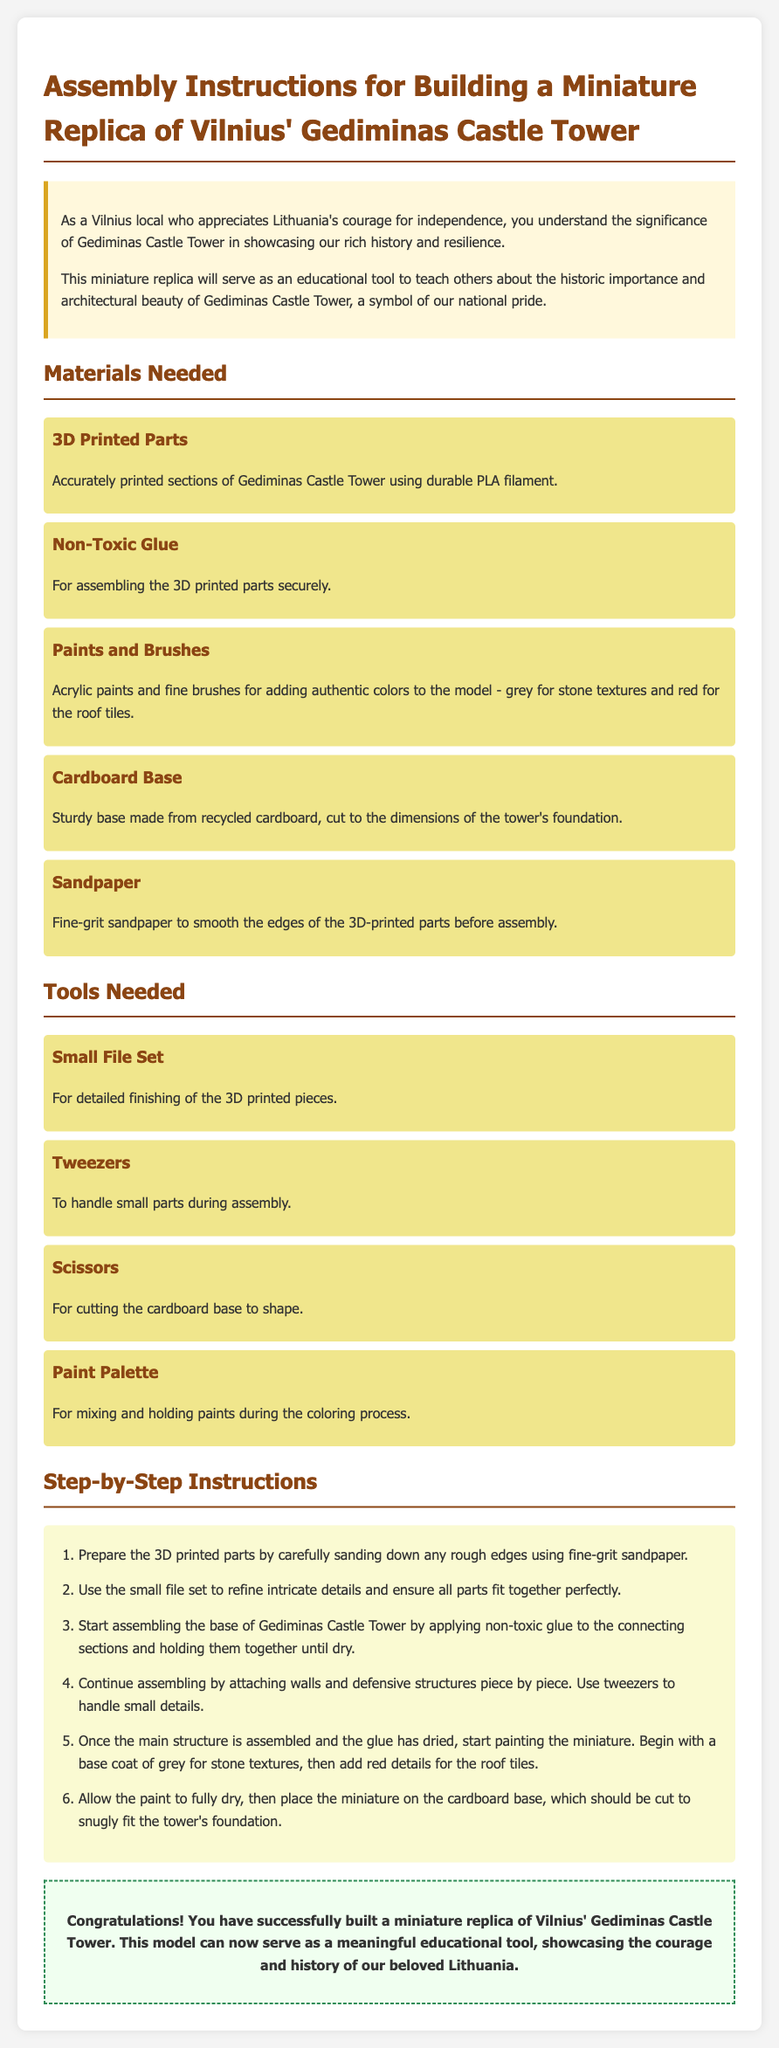What is the title of the document? The title of the document is indicated in the header as "Assembly Instructions for Building a Miniature Replica of Vilnius' Gediminas Castle Tower".
Answer: Assembly Instructions for Building a Miniature Replica of Vilnius' Gediminas Castle Tower How many materials are listed? The materials section lists five distinct items required for the assembly.
Answer: 5 What type of glue is mentioned? The document specifies the kind of glue needed for assembly, which is mentioned as "non-toxic glue".
Answer: Non-Toxic Glue What is the first step in the assembly instructions? The first step details preparing the 3D printed parts by sanding down rough edges.
Answer: Prepare the 3D printed parts by carefully sanding down any rough edges What colors are suggested for painting the model? The document mentions two specific colors for painting, grey for stone textures and red for roof tiles.
Answer: Grey for stone textures, red for roof tiles What tool is recommended for cutting the cardboard base? The tools section specifies scissors as the tool for shaping the cardboard base.
Answer: Scissors How is the conclusion framed in the document? The conclusion recognizes the successful completion of the replica and its educational purpose regarding Lithuania's courage and history.
Answer: Congratulations! You have successfully built a miniature replica of Vilnius' Gediminas Castle Tower What is the purpose of building the miniature replica? The document mentions the educational objective of the replica, related to showcasing historic importance and architectural beauty.
Answer: Educational tool to teach others about the historic importance and architectural beauty 